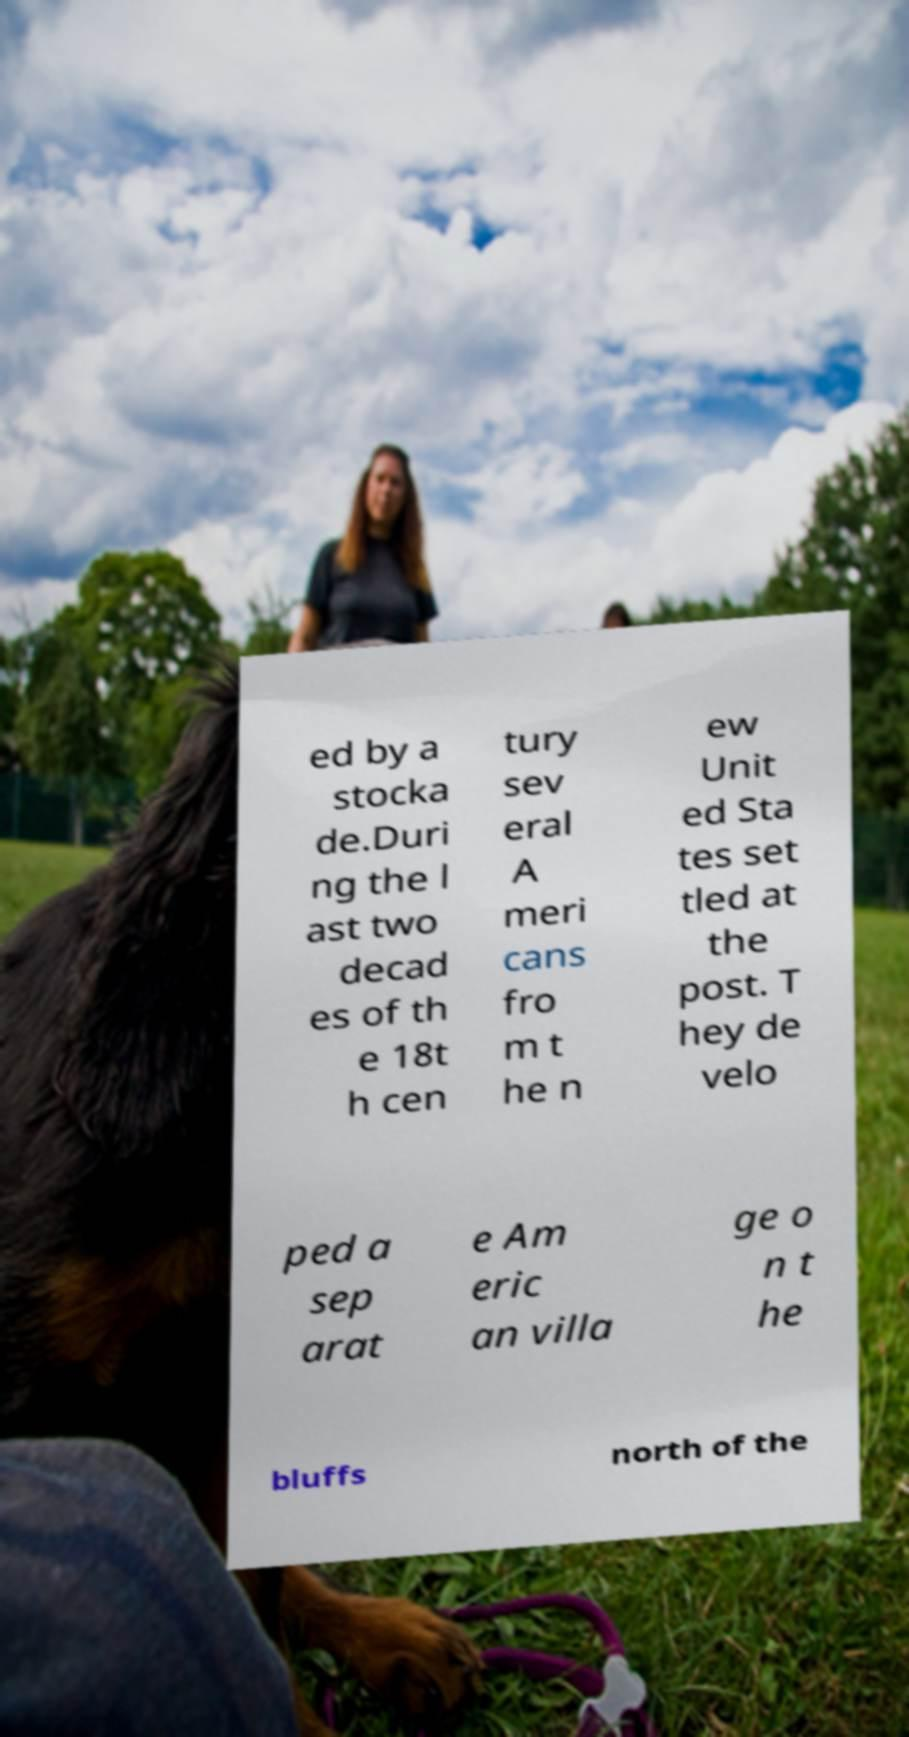There's text embedded in this image that I need extracted. Can you transcribe it verbatim? ed by a stocka de.Duri ng the l ast two decad es of th e 18t h cen tury sev eral A meri cans fro m t he n ew Unit ed Sta tes set tled at the post. T hey de velo ped a sep arat e Am eric an villa ge o n t he bluffs north of the 